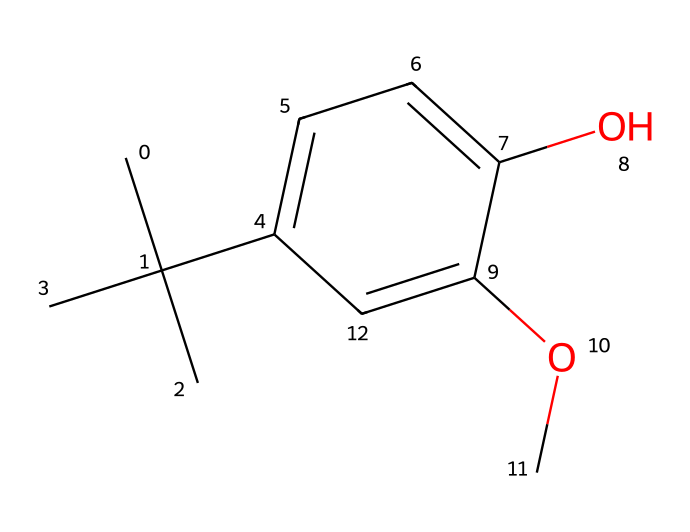how many carbon atoms are in this molecule? By examining the SMILES representation, we note that the molecule's structure indicates branching and cyclic rings containing carbon atoms. Counting each "C" in the SMILES, there are 11 carbon atoms present.
Answer: 11 how many hydroxyl (OH) groups are present? The presence of the "O" indicates an oxygen atom, and when combined with an adjacent hydrogen, it forms a hydroxyl (OH) group. In the structure, we see one hydroxyl group from the "O" that can be counted.
Answer: 1 what is the class of this preservative? The structure shows that it has aromatic rings and is characterized by an ether and an alcohol. This class of materials, given its application in preserving, can be classified as a phenolic antioxidant.
Answer: phenolic antioxidant how does the branching affect its stability? The branching in the molecule increases steric hindrance, which can enhance its stability by reducing the likelihood of oxidative reactions associated with synthetic fibers. More bulky groups can hinder reactions that would cause degradation.
Answer: increases stability what is the role of the methoxy (-OCH3) group in the structure? The methoxy group donates an electron to the aromatic system, stabilizing it and enhancing the compound's overall antioxidant properties. This means it plays a crucial role in the functionality of BHA as a preservative.
Answer: enhances antioxidant properties does this molecule contain any double bonds? The SMILES representation does not indicate the presence of any double bonded carbons, as all carbon connections present appear to be single bonds, particularly in the aliphatic and aromatic regions.
Answer: no what is the significance of using BHA in synthetic fiber preservation? BHA provides its antioxidant activity to prevent oxidative damage to synthetic fibers, which can prolong the lifespan and maintain the quality of textiles by preventing degradation.
Answer: prevents oxidative damage 